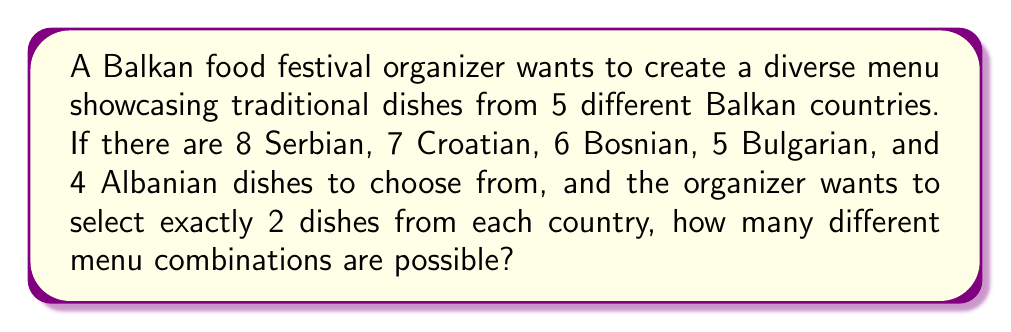Show me your answer to this math problem. Let's approach this step-by-step:

1) We need to select 2 dishes from each country independently. This is a combination problem for each country.

2) For each country, we use the combination formula:
   $C(n,r) = \frac{n!}{r!(n-r)!}$
   where $n$ is the total number of dishes for a country, and $r$ is the number we're selecting (2 in this case).

3) Let's calculate for each country:

   Serbia: $C(8,2) = \frac{8!}{2!(8-2)!} = \frac{8!}{2!6!} = 28$
   
   Croatia: $C(7,2) = \frac{7!}{2!(7-2)!} = \frac{7!}{2!5!} = 21$
   
   Bosnia: $C(6,2) = \frac{6!}{2!(6-2)!} = \frac{6!}{2!4!} = 15$
   
   Bulgaria: $C(5,2) = \frac{5!}{2!(5-2)!} = \frac{5!}{2!3!} = 10$
   
   Albania: $C(4,2) = \frac{4!}{2!(4-2)!} = \frac{4!}{2!2!} = 6$

4) Since we need to select dishes from all countries, and the selection for each country is independent, we multiply these results:

   Total combinations = $28 \times 21 \times 15 \times 10 \times 6$

5) Calculating this:
   $28 \times 21 \times 15 \times 10 \times 6 = 529,200$

Therefore, there are 529,200 different possible menu combinations.
Answer: 529,200 